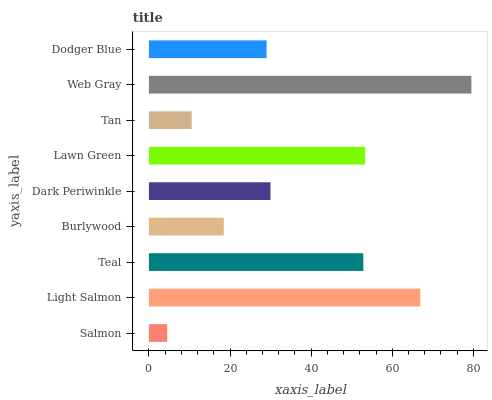Is Salmon the minimum?
Answer yes or no. Yes. Is Web Gray the maximum?
Answer yes or no. Yes. Is Light Salmon the minimum?
Answer yes or no. No. Is Light Salmon the maximum?
Answer yes or no. No. Is Light Salmon greater than Salmon?
Answer yes or no. Yes. Is Salmon less than Light Salmon?
Answer yes or no. Yes. Is Salmon greater than Light Salmon?
Answer yes or no. No. Is Light Salmon less than Salmon?
Answer yes or no. No. Is Dark Periwinkle the high median?
Answer yes or no. Yes. Is Dark Periwinkle the low median?
Answer yes or no. Yes. Is Lawn Green the high median?
Answer yes or no. No. Is Dodger Blue the low median?
Answer yes or no. No. 